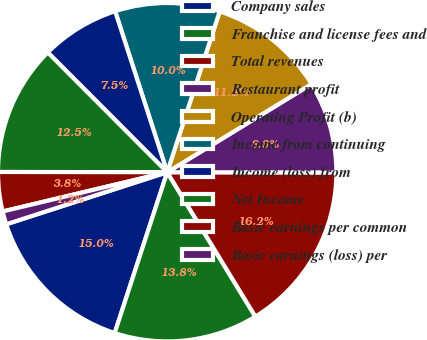<chart> <loc_0><loc_0><loc_500><loc_500><pie_chart><fcel>Company sales<fcel>Franchise and license fees and<fcel>Total revenues<fcel>Restaurant profit<fcel>Operating Profit (b)<fcel>Income from continuing<fcel>Income (loss) from<fcel>Net Income<fcel>Basic earnings per common<fcel>Basic earnings (loss) per<nl><fcel>15.0%<fcel>13.75%<fcel>16.25%<fcel>8.75%<fcel>11.25%<fcel>10.0%<fcel>7.5%<fcel>12.5%<fcel>3.75%<fcel>1.25%<nl></chart> 